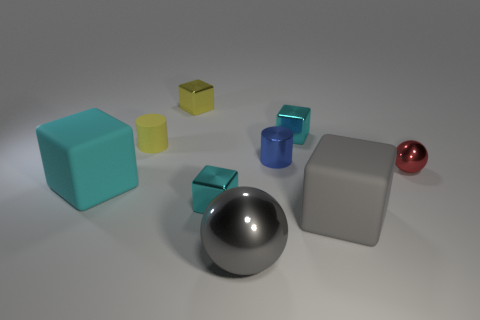What is the color of the shiny ball that is behind the matte thing that is left of the yellow cylinder?
Your response must be concise. Red. The big cube in front of the small cyan thing in front of the rubber cube that is to the left of the gray cube is made of what material?
Ensure brevity in your answer.  Rubber. There is a shiny ball that is right of the blue cylinder; does it have the same size as the gray sphere?
Ensure brevity in your answer.  No. What is the material of the cyan block that is to the left of the small matte thing?
Ensure brevity in your answer.  Rubber. Is the number of yellow things greater than the number of small spheres?
Ensure brevity in your answer.  Yes. How many objects are either cyan metal blocks that are to the left of the large shiny object or tiny green metallic blocks?
Ensure brevity in your answer.  1. How many tiny cyan cubes are on the right side of the matte object to the right of the yellow rubber cylinder?
Give a very brief answer. 0. There is a cyan thing that is on the left side of the cube behind the small cyan shiny thing behind the red sphere; what size is it?
Provide a short and direct response. Large. Do the large rubber block that is on the right side of the yellow matte thing and the big metal sphere have the same color?
Your answer should be compact. Yes. There is a yellow object that is the same shape as the cyan rubber thing; what is its size?
Your response must be concise. Small. 